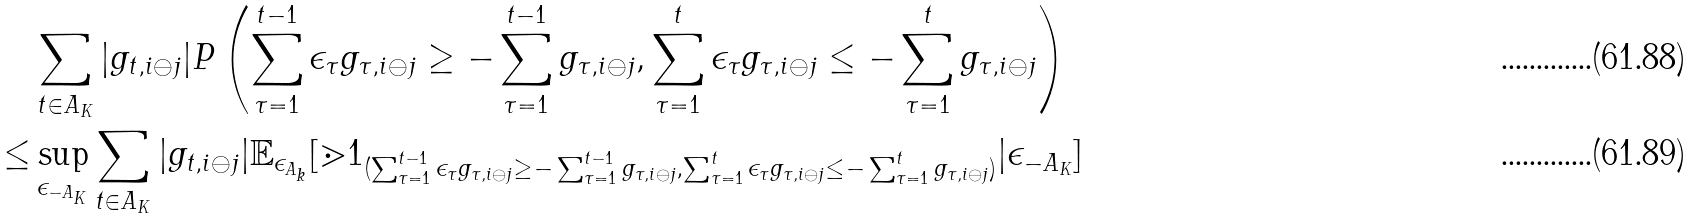Convert formula to latex. <formula><loc_0><loc_0><loc_500><loc_500>& \sum _ { t \in A _ { K } } | g _ { t , i \ominus j } | P \left ( \sum _ { \tau = 1 } ^ { t - 1 } \epsilon _ { \tau } g _ { \tau , i \ominus j } \geq - \sum _ { \tau = 1 } ^ { t - 1 } g _ { \tau , i \ominus j } , \sum _ { \tau = 1 } ^ { t } \epsilon _ { \tau } g _ { \tau , i \ominus j } \leq - \sum _ { \tau = 1 } ^ { t } g _ { \tau , i \ominus j } \right ) \\ \leq & \sup _ { \epsilon _ { - A _ { K } } } \sum _ { t \in A _ { K } } | g _ { t , i \ominus j } | \mathbb { E } _ { \epsilon _ { A _ { k } } } [ \mathbb { m } { 1 } _ { ( \sum _ { \tau = 1 } ^ { t - 1 } \epsilon _ { \tau } g _ { \tau , i \ominus j } \geq - \sum _ { \tau = 1 } ^ { t - 1 } g _ { \tau , i \ominus j } , \sum _ { \tau = 1 } ^ { t } \epsilon _ { \tau } g _ { \tau , i \ominus j } \leq - \sum _ { \tau = 1 } ^ { t } g _ { \tau , i \ominus j } ) } | \epsilon _ { - A _ { K } } ]</formula> 